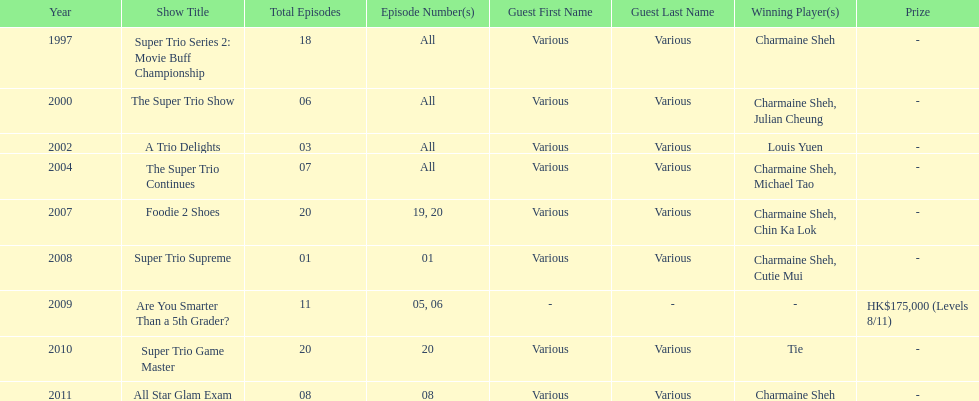How many episodes was charmaine sheh on in the variety show super trio 2: movie buff champions 18. 